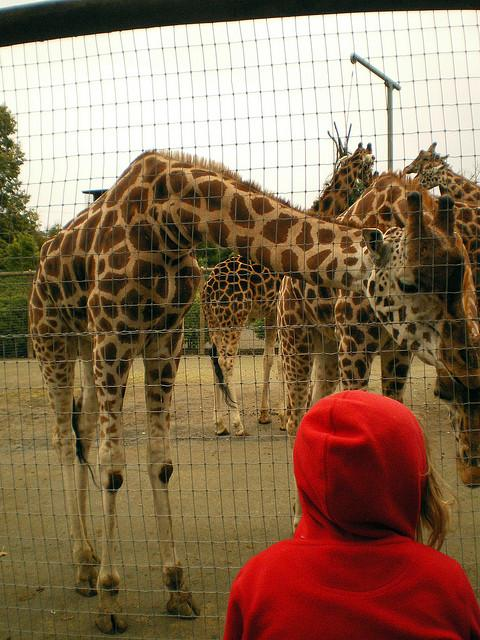How many of the giraffes are attentive to the child? two 